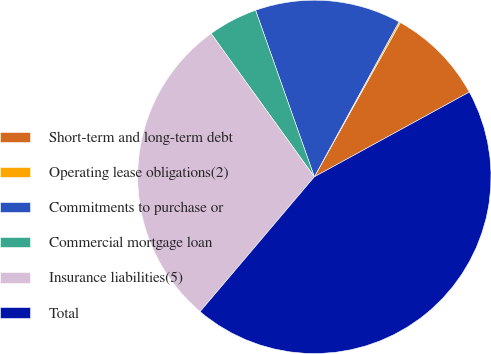Convert chart to OTSL. <chart><loc_0><loc_0><loc_500><loc_500><pie_chart><fcel>Short-term and long-term debt<fcel>Operating lease obligations(2)<fcel>Commitments to purchase or<fcel>Commercial mortgage loan<fcel>Insurance liabilities(5)<fcel>Total<nl><fcel>8.94%<fcel>0.14%<fcel>13.35%<fcel>4.54%<fcel>28.87%<fcel>44.16%<nl></chart> 